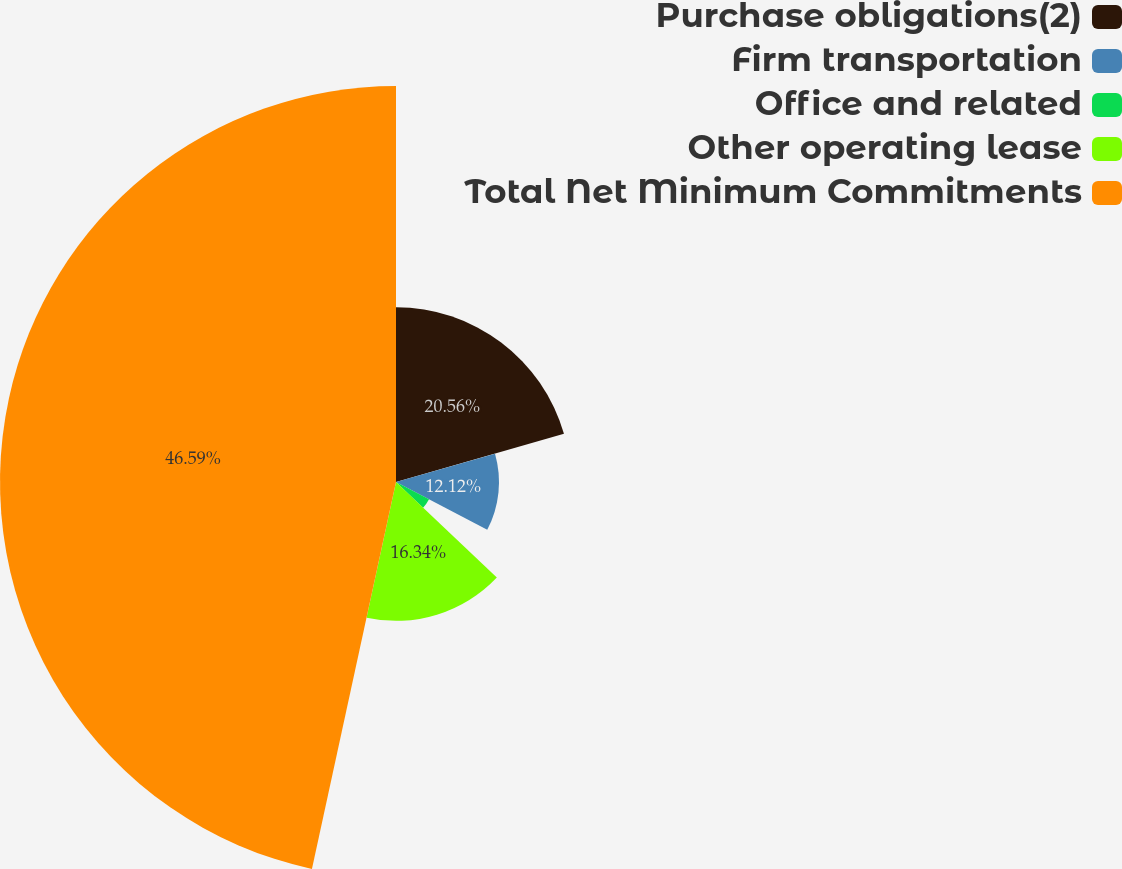<chart> <loc_0><loc_0><loc_500><loc_500><pie_chart><fcel>Purchase obligations(2)<fcel>Firm transportation<fcel>Office and related<fcel>Other operating lease<fcel>Total Net Minimum Commitments<nl><fcel>20.56%<fcel>12.12%<fcel>4.39%<fcel>16.34%<fcel>46.6%<nl></chart> 